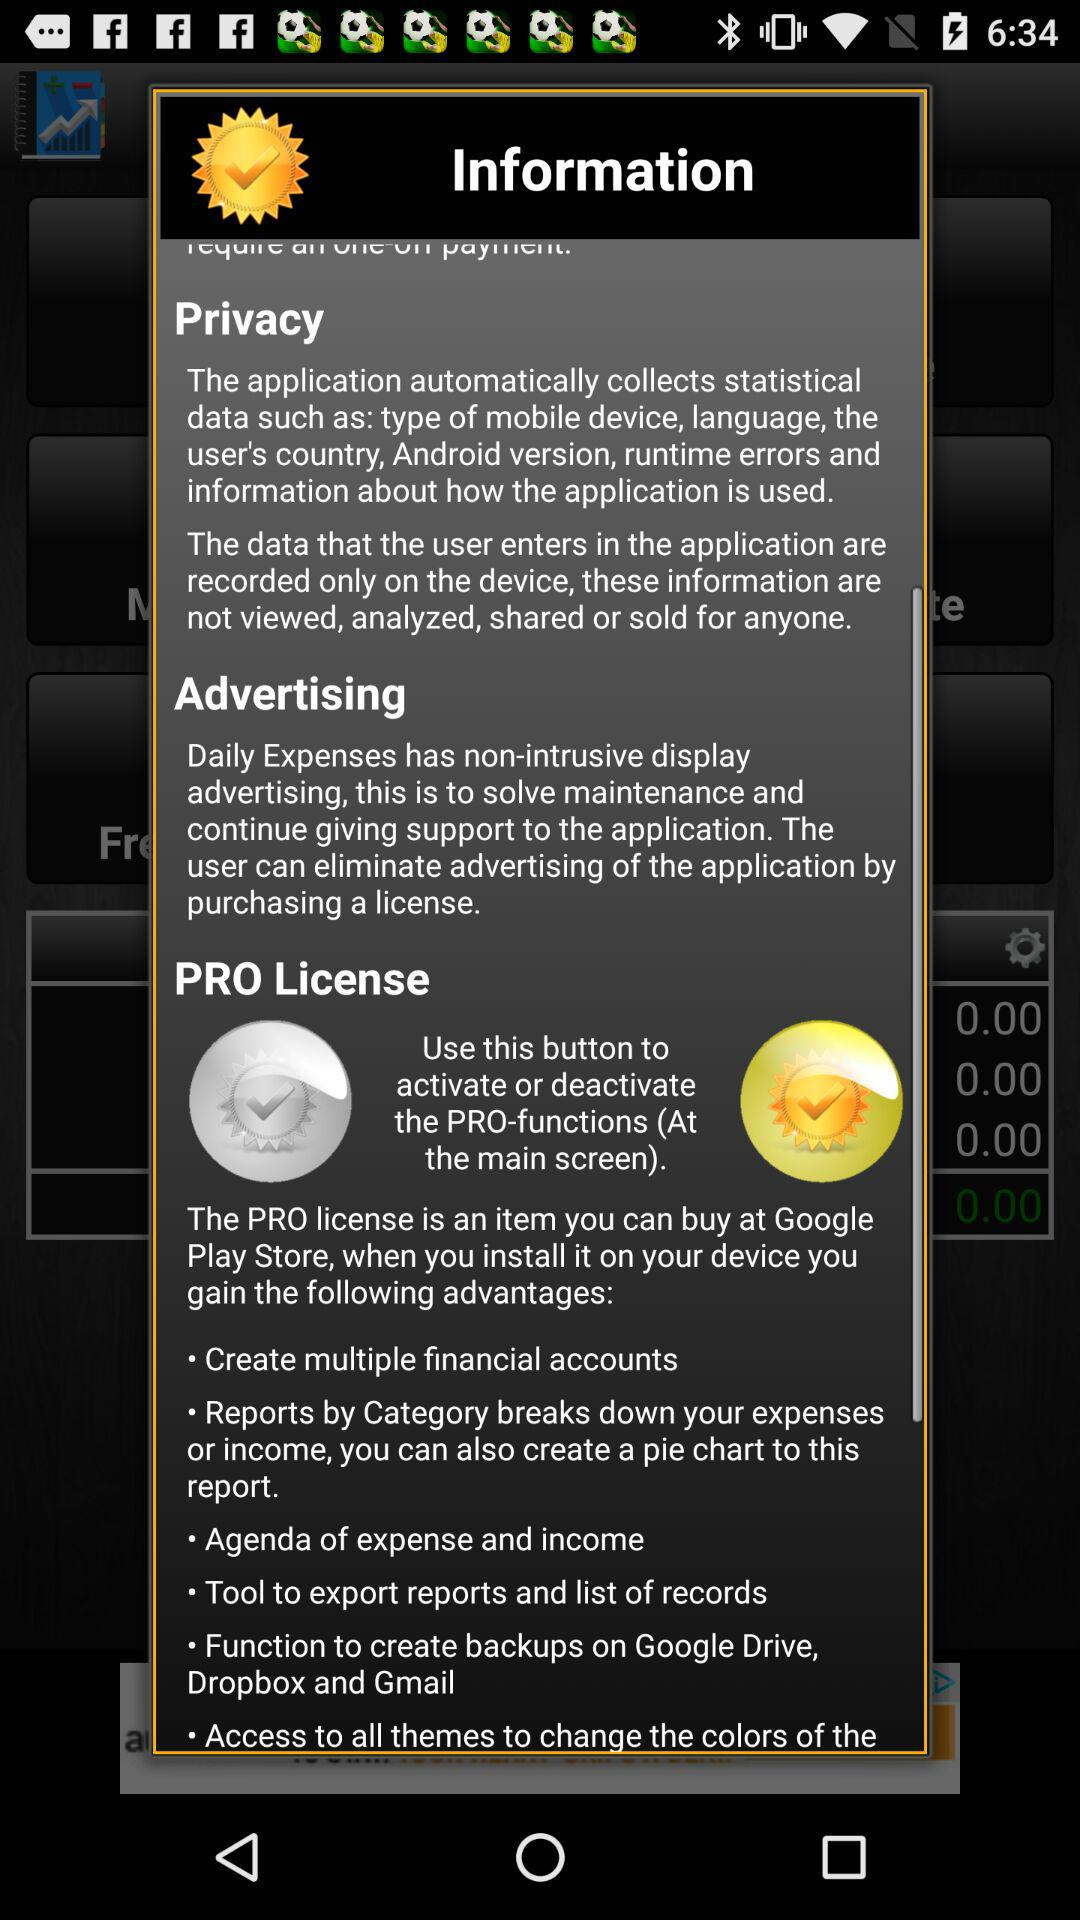How many features are included in the PRO license?
Answer the question using a single word or phrase. 6 